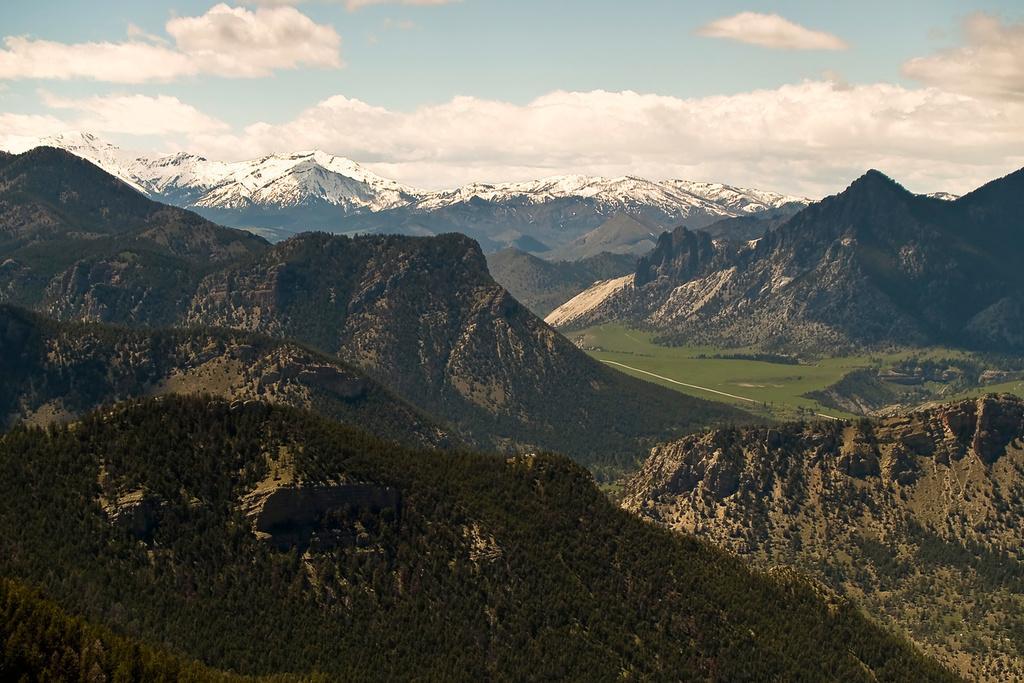Please provide a concise description of this image. This is an outside view. In this image, I can see many trees and mountains. At the top of the image I can see the sky and clouds. 